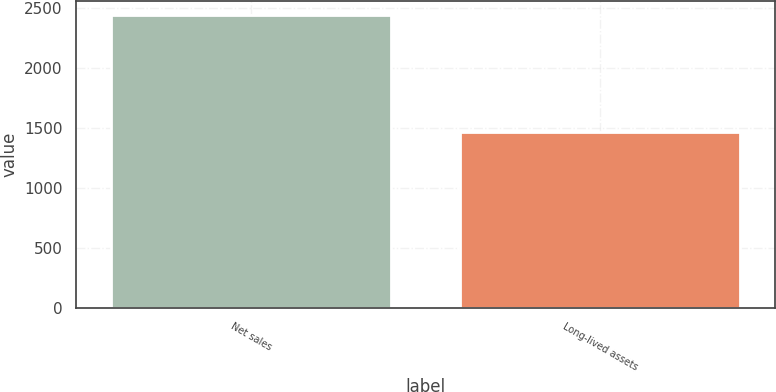Convert chart. <chart><loc_0><loc_0><loc_500><loc_500><bar_chart><fcel>Net sales<fcel>Long-lived assets<nl><fcel>2438.1<fcel>1462.2<nl></chart> 